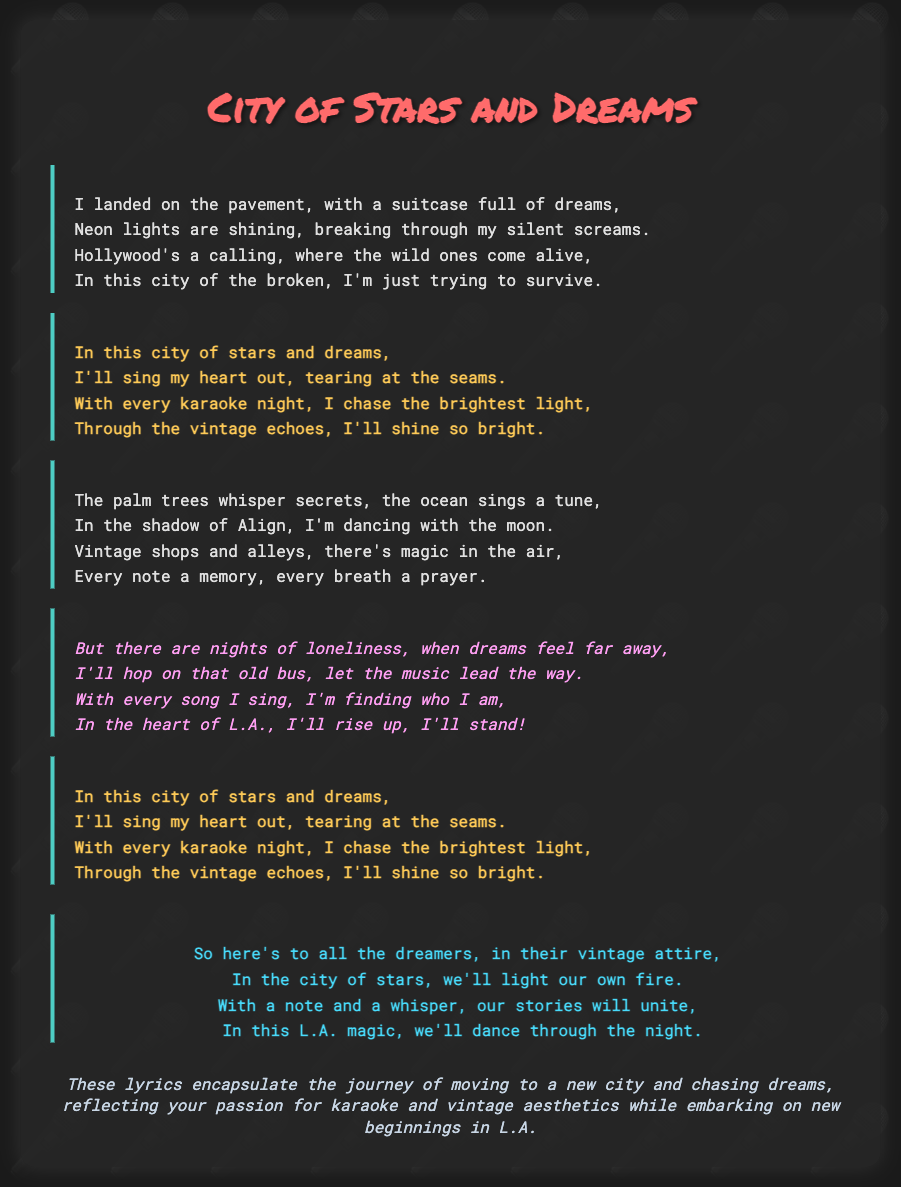What is the title of the song? The title appears prominently at the top of the document, styled in a large font.
Answer: City of Stars and Dreams How many verses are in the song? The song includes two verses presented in the document.
Answer: 2 What color is used for the chorus lyrics? The chorus lyrics are styled with a specific font color noted in the document.
Answer: #feca57 What is being pursued in the song? The song revolves around the idea of pursuing dreams in a new city.
Answer: Dreams What metaphor is used for the city in the chorus? The city is described with a specific phrase highlighting its characteristics in the chorus.
Answer: City of stars and dreams What kind of attire is mentioned in the outro? The outro specifies a particular style of clothing associated with the dreamers.
Answer: Vintage attire What does the singer plan to do with every karaoke night? The lyrics emphasize an action the singer takes during karaoke nights in pursuit of their goals.
Answer: Chase the brightest light What is the main emotional theme in the bridge? The bridge expresses a feeling related to the challenges faced while chasing dreams.
Answer: Loneliness What is a recurring element connected to the vintage aesthetic? The song's narrative intertwines with a specific aspect that showcases its vintage theme.
Answer: Vintage shops and alleys 